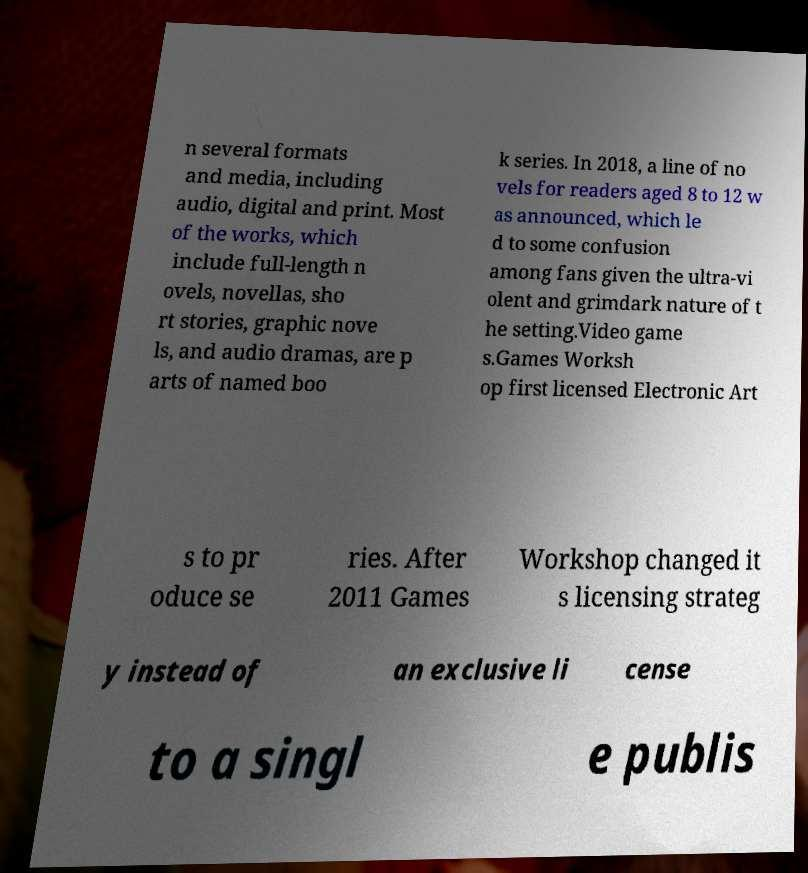Can you accurately transcribe the text from the provided image for me? n several formats and media, including audio, digital and print. Most of the works, which include full-length n ovels, novellas, sho rt stories, graphic nove ls, and audio dramas, are p arts of named boo k series. In 2018, a line of no vels for readers aged 8 to 12 w as announced, which le d to some confusion among fans given the ultra-vi olent and grimdark nature of t he setting.Video game s.Games Worksh op first licensed Electronic Art s to pr oduce se ries. After 2011 Games Workshop changed it s licensing strateg y instead of an exclusive li cense to a singl e publis 